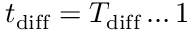Convert formula to latex. <formula><loc_0><loc_0><loc_500><loc_500>t _ { d i f f } = T _ { d i f f } \dots 1</formula> 